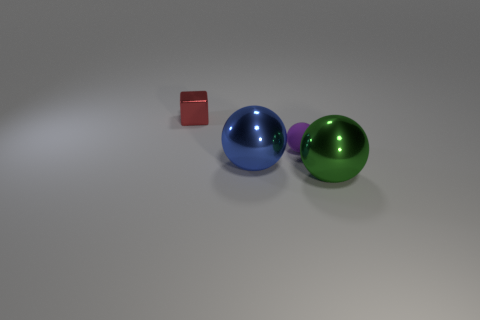What number of big blue spheres are behind the tiny red shiny object? There are no big blue spheres positioned behind the small red shiny object; both big blue and green spheres are in front of it. 